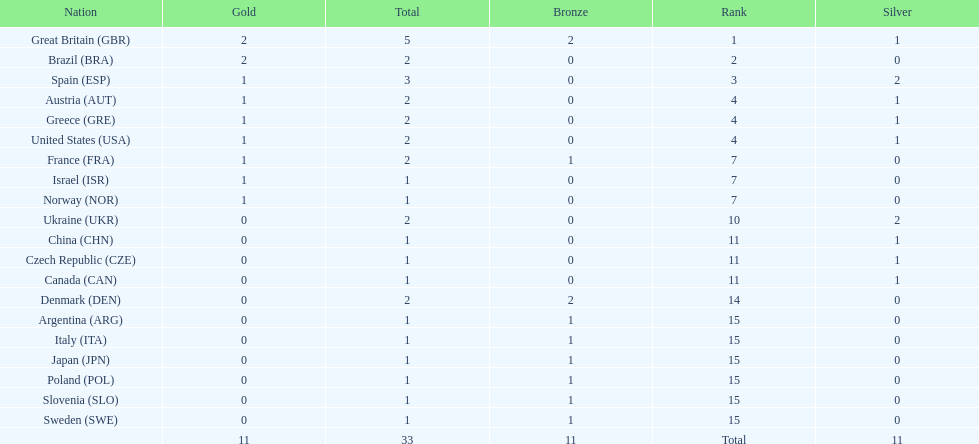What was the total number of medals won by united states? 2. 